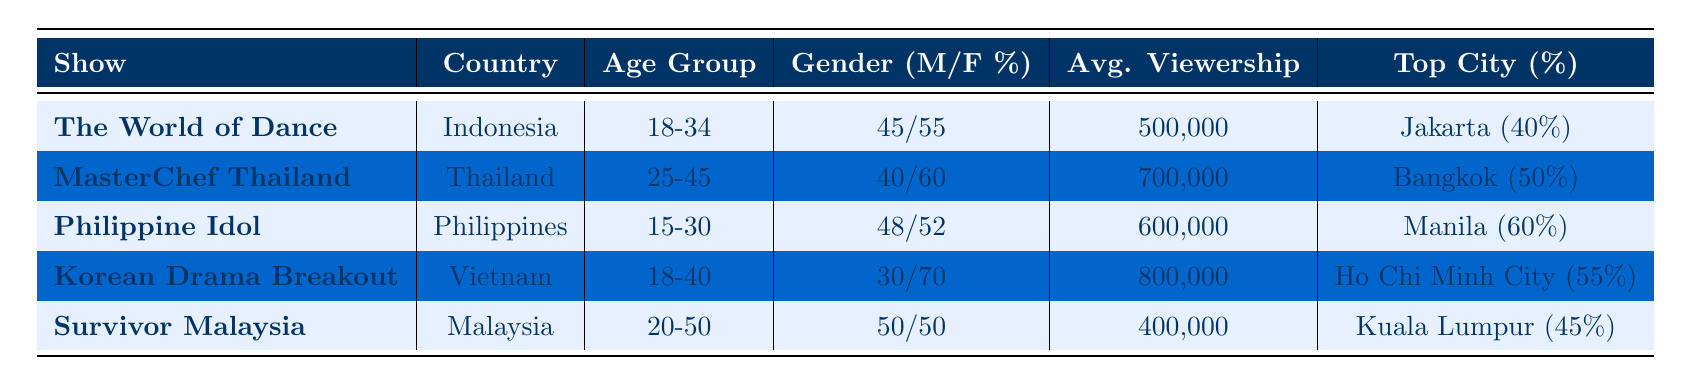What is the average viewership of "Korean Drama Breakout"? The average viewership for "Korean Drama Breakout" is stated directly in the table as 800,000.
Answer: 800,000 Which country has the highest average viewership among the listed shows? Comparing the average viewership values from the table, "Korean Drama Breakout" from Vietnam has the highest at 800,000, while the others are lower.
Answer: Vietnam What percentage of viewers for "MasterChef Thailand" are female? The table indicates that the gender distribution for "MasterChef Thailand" is 40% male and 60% female, so the percentage of female viewers is 60%.
Answer: 60% Is the top city for "Philippine Idol" Manila? The table shows that the top city for "Philippine Idol" is indeed Manila, as it accounts for 60% of the viewership.
Answer: Yes How many total viewers are there for "The World of Dance" and "Survivor Malaysia"? The average viewership for "The World of Dance" is 500,000 and for "Survivor Malaysia" it is 400,000. Adding these values gives 500,000 + 400,000 = 900,000 total viewers.
Answer: 900,000 What is the average age range of viewers across all shows? The age ranges are 18-34 for "The World of Dance", 25-45 for "MasterChef Thailand", 15-30 for "Philippine Idol", 18-40 for "Korean Drama Breakout", and 20-50 for "Survivor Malaysia". The average of these ranges cannot be calculated directly without specific values for each. Therefore, a summary indicates a likely median or central tendency in the 20s to 40s range.
Answer: Approximately 20s to 40s Which show has the most balanced gender distribution? The gender distributions are as follows: "The World of Dance" (45/55), "MasterChef Thailand" (40/60), "Philippine Idol" (48/52), "Korean Drama Breakout" (30/70), and "Survivor Malaysia" (50/50). The most balanced distribution is 50/50 from "Survivor Malaysia".
Answer: Survivor Malaysia Which show has the lowest average viewership? By reviewing the average viewership, "Survivor Malaysia" has the lowest at 400,000 compared to the other shows listed.
Answer: 400,000 What is the key city for viewership for "Korean Drama Breakout"? According to the table, "Korean Drama Breakout" has the top city as Ho Chi Minh City, which represents 55% of its viewership.
Answer: Ho Chi Minh City What is the difference in average viewership between "MasterChef Thailand" and "Survivor Malaysia"? The average viewership for "MasterChef Thailand" is 700,000 and for "Survivor Malaysia" is 400,000. The difference is 700,000 - 400,000 = 300,000.
Answer: 300,000 